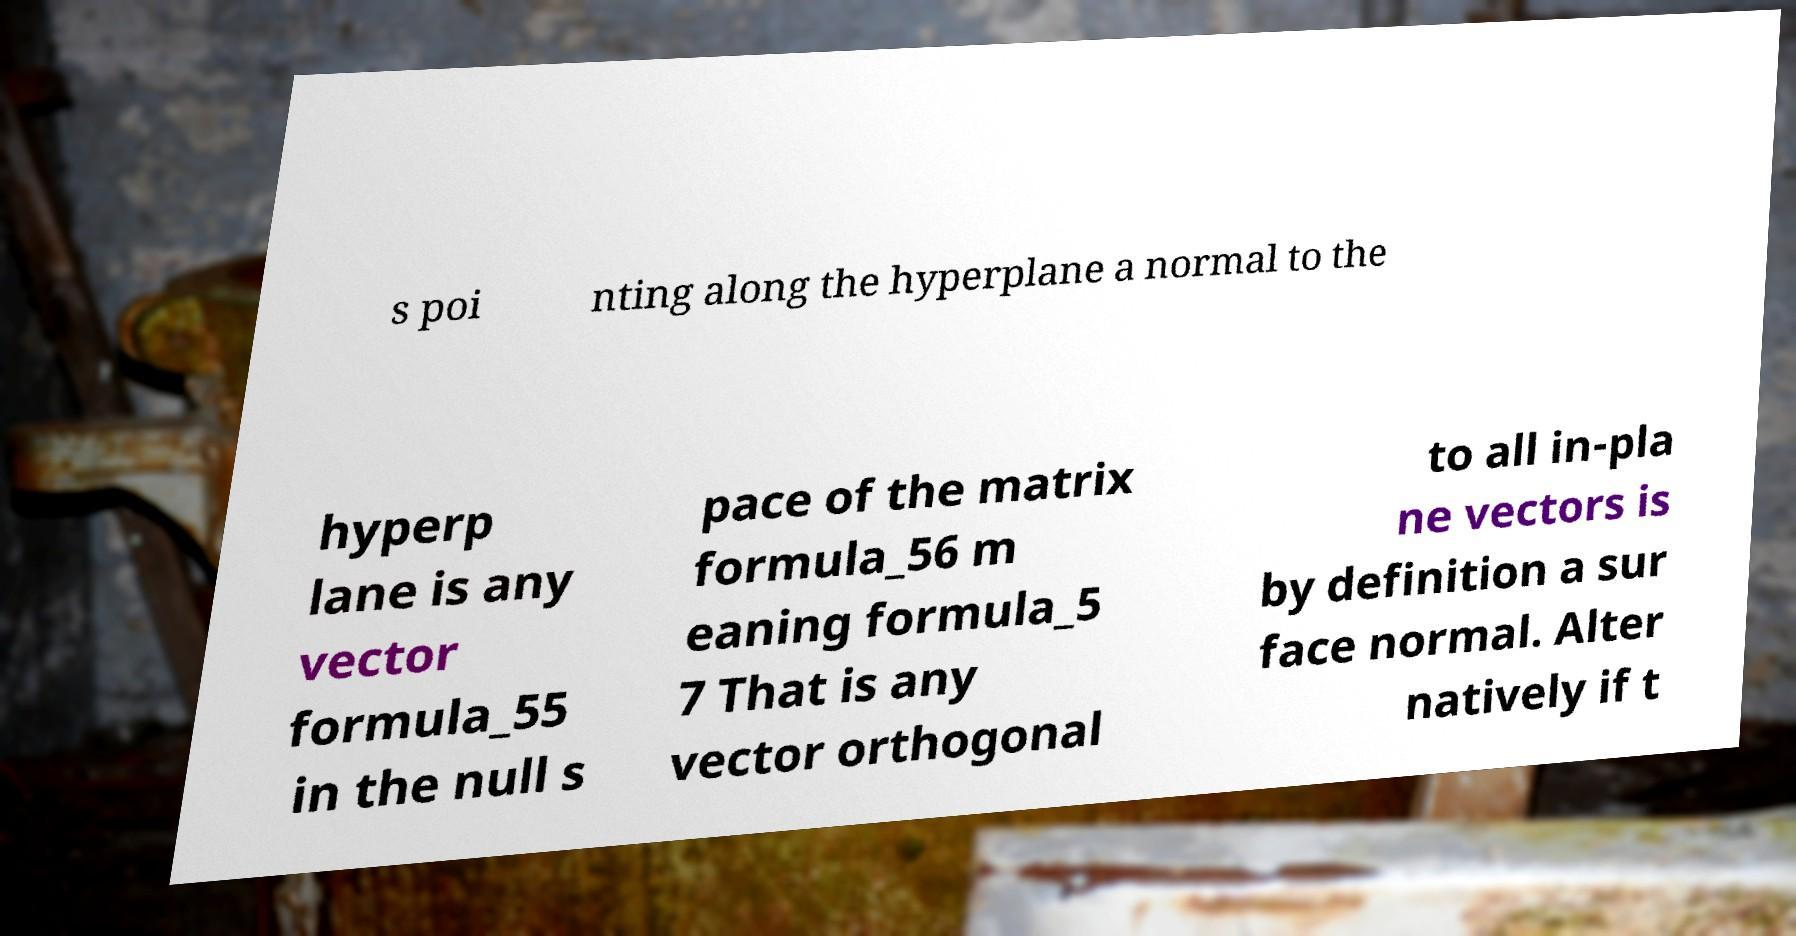Can you accurately transcribe the text from the provided image for me? s poi nting along the hyperplane a normal to the hyperp lane is any vector formula_55 in the null s pace of the matrix formula_56 m eaning formula_5 7 That is any vector orthogonal to all in-pla ne vectors is by definition a sur face normal. Alter natively if t 